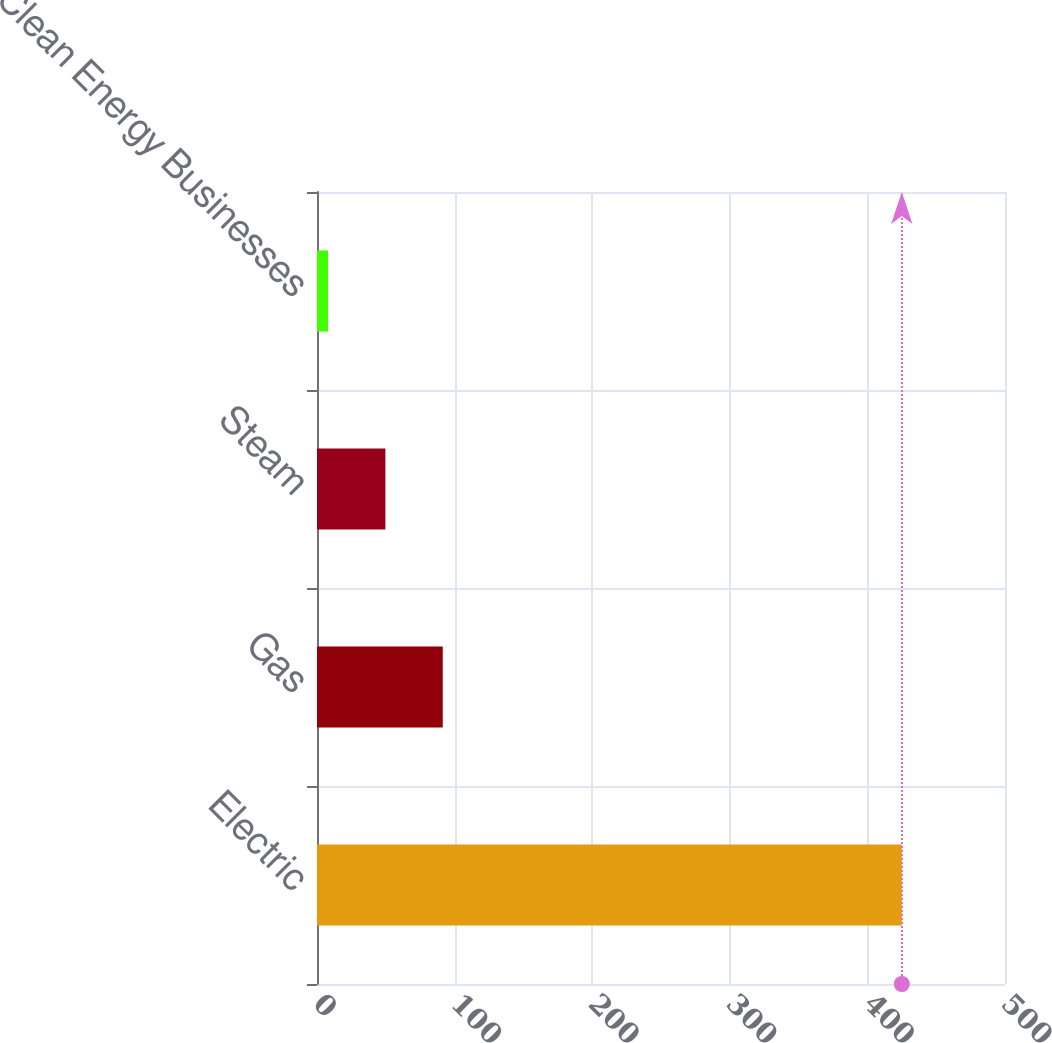<chart> <loc_0><loc_0><loc_500><loc_500><bar_chart><fcel>Electric<fcel>Gas<fcel>Steam<fcel>Clean Energy Businesses<nl><fcel>425<fcel>91.4<fcel>49.7<fcel>8<nl></chart> 